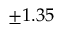Convert formula to latex. <formula><loc_0><loc_0><loc_500><loc_500>\pm 1 . 3 5</formula> 